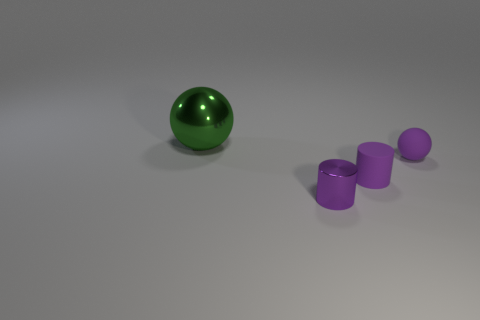Is the number of tiny rubber spheres behind the big green metal ball greater than the number of purple metal objects?
Your response must be concise. No. What number of other things are there of the same size as the purple metal cylinder?
Your answer should be very brief. 2. There is a matte ball; what number of spheres are left of it?
Your answer should be compact. 1. Are there the same number of small cylinders that are in front of the big green shiny sphere and small purple matte things on the right side of the tiny matte sphere?
Provide a short and direct response. No. There is another purple object that is the same shape as the purple metal thing; what is its size?
Make the answer very short. Small. The tiny purple rubber thing that is behind the tiny purple rubber cylinder has what shape?
Keep it short and to the point. Sphere. Do the sphere in front of the big green object and the thing behind the purple sphere have the same material?
Provide a short and direct response. No. What is the shape of the small metallic thing?
Your answer should be compact. Cylinder. Are there the same number of purple cylinders that are left of the green shiny thing and large brown cylinders?
Your response must be concise. Yes. What is the size of the ball that is the same color as the tiny shiny cylinder?
Offer a terse response. Small. 